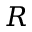Convert formula to latex. <formula><loc_0><loc_0><loc_500><loc_500>R</formula> 